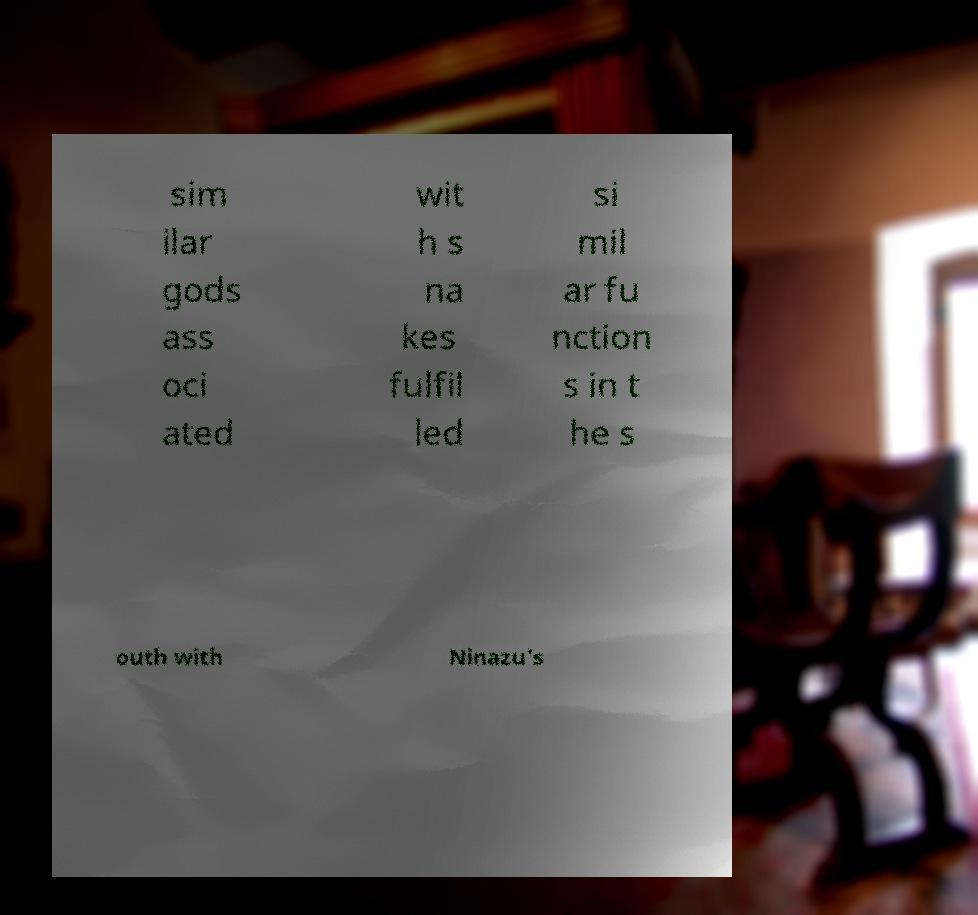What messages or text are displayed in this image? I need them in a readable, typed format. sim ilar gods ass oci ated wit h s na kes fulfil led si mil ar fu nction s in t he s outh with Ninazu's 